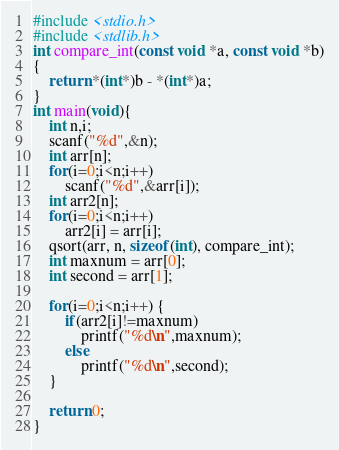<code> <loc_0><loc_0><loc_500><loc_500><_C_>#include <stdio.h>
#include <stdlib.h>
int compare_int(const void *a, const void *b)
{
    return *(int*)b - *(int*)a;
}
int main(void){
    int n,i;
    scanf("%d",&n);
    int arr[n];
    for(i=0;i<n;i++)
        scanf("%d",&arr[i]);
    int arr2[n];
    for(i=0;i<n;i++)
        arr2[i] = arr[i];
    qsort(arr, n, sizeof(int), compare_int);
    int maxnum = arr[0];
    int second = arr[1];

    for(i=0;i<n;i++) {
        if(arr2[i]!=maxnum)
            printf("%d\n",maxnum);
        else
            printf("%d\n",second);
    }

    return 0;
}</code> 